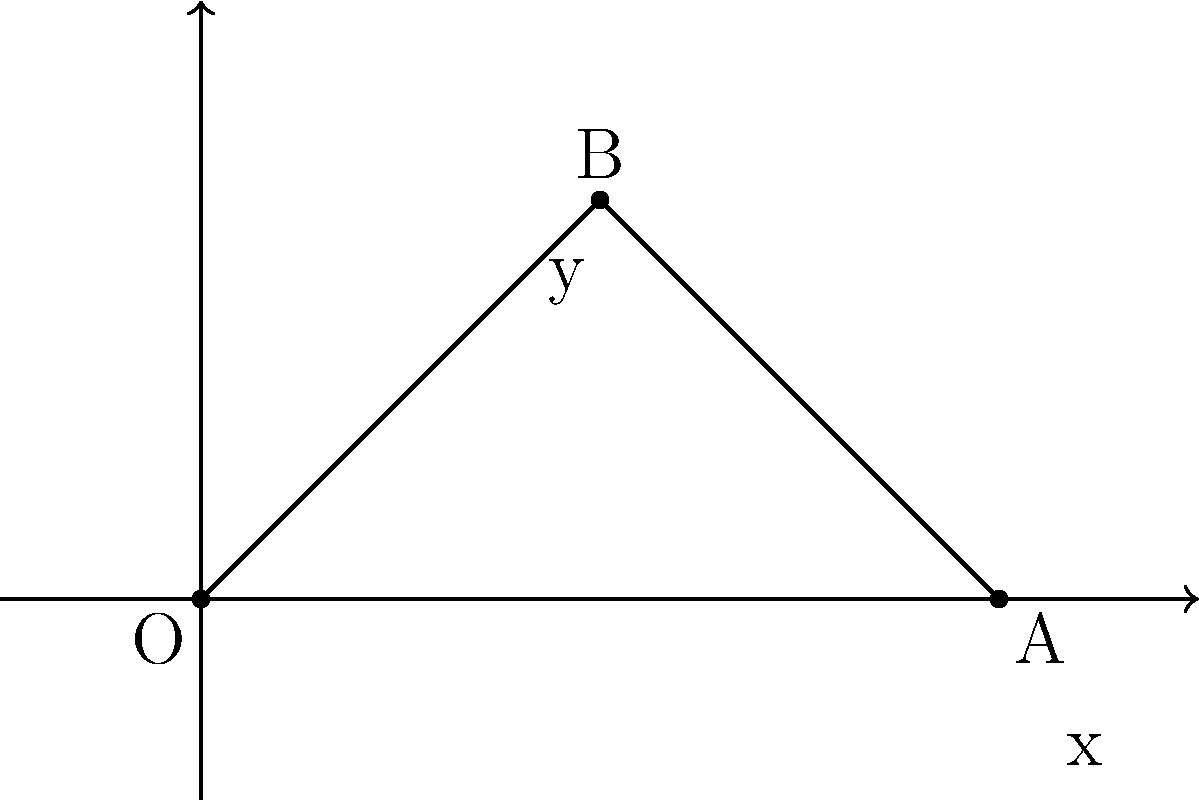In the context of early Greek philosophy, particularly Pythagoras' teachings, which geometric shape does this coordinate system most closely represent, and how does it relate to their understanding of spatial relationships? 1. The diagram shows a right-angled triangle in a basic coordinate system.

2. Pythagoras and his followers were particularly interested in the properties of triangles, especially right-angled triangles.

3. The Pythagoreans believed that numbers and geometric shapes were the fundamental principles of the universe.

4. This right-angled triangle relates to the famous Pythagorean theorem: $a^2 + b^2 = c^2$, where $a$ and $b$ are the lengths of the two shorter sides (catheti), and $c$ is the length of the longest side (hypotenuse).

5. In the coordinate system, we can see:
   - The x-axis represents one cathetus
   - The y-axis represents the other cathetus
   - The hypotenuse connects the two points (A and B) in space

6. This representation shows how the Pythagoreans began to conceptualize space in terms of measurable, numerical relationships.

7. The coordinate system itself, while not explicitly used by the ancient Greeks, illustrates how their ideas about spatial relationships could be visualized in a more modern format.

8. This approach laid the groundwork for later developments in geometry and mathematics, influencing philosophers and scientists for centuries to come.
Answer: Right-angled triangle; Pythagorean theorem 